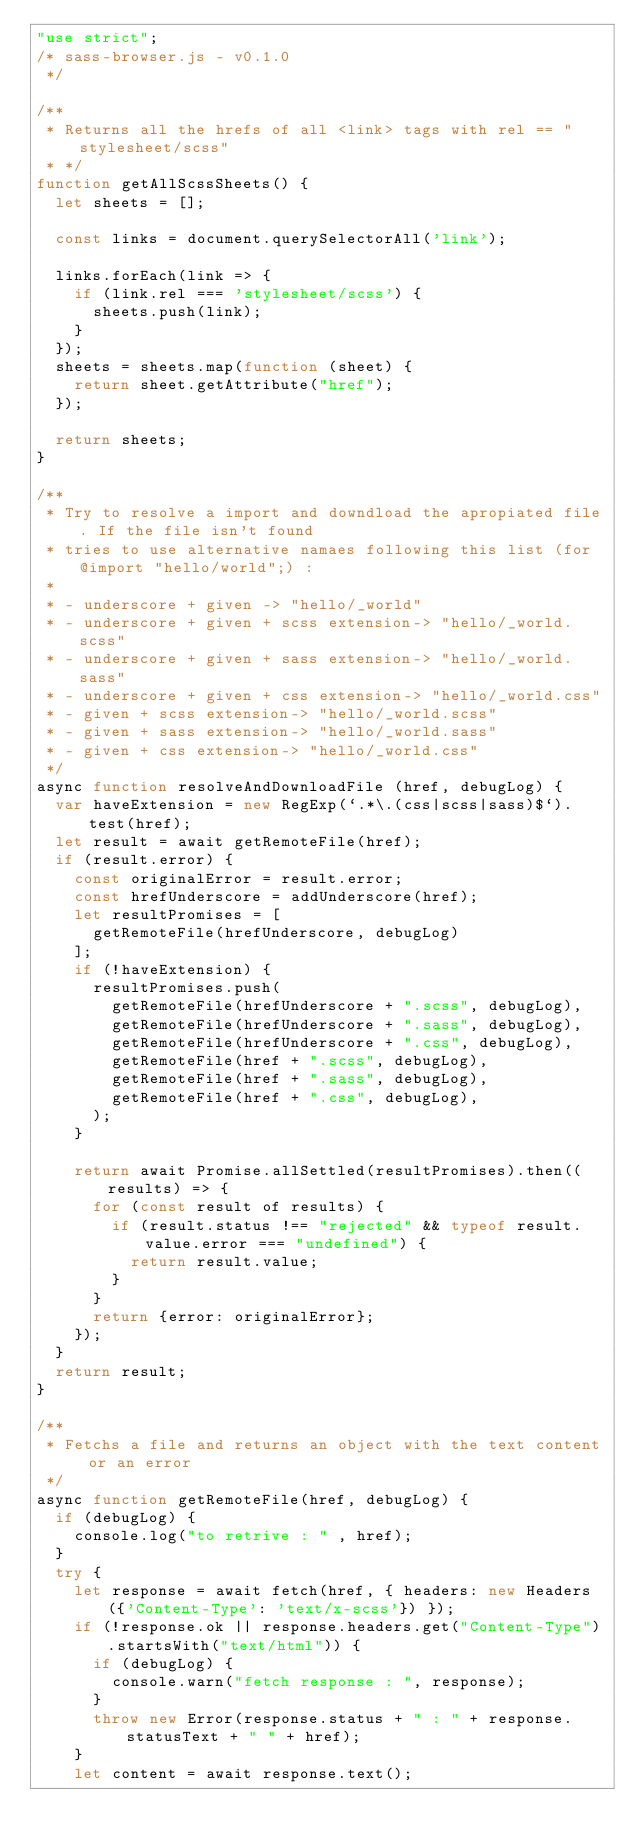Convert code to text. <code><loc_0><loc_0><loc_500><loc_500><_JavaScript_>"use strict";
/* sass-browser.js - v0.1.0
 */

/**
 * Returns all the hrefs of all <link> tags with rel == "stylesheet/scss"
 * */
function getAllScssSheets() {
  let sheets = [];

  const links = document.querySelectorAll('link');

  links.forEach(link => {
    if (link.rel === 'stylesheet/scss') {
      sheets.push(link);
    }
  });
  sheets = sheets.map(function (sheet) {
    return sheet.getAttribute("href");
  });

  return sheets;
}

/**
 * Try to resolve a import and downdload the apropiated file. If the file isn't found
 * tries to use alternative namaes following this list (for @import "hello/world";) :
 *
 * - underscore + given -> "hello/_world"
 * - underscore + given + scss extension-> "hello/_world.scss"
 * - underscore + given + sass extension-> "hello/_world.sass"
 * - underscore + given + css extension-> "hello/_world.css"
 * - given + scss extension-> "hello/_world.scss"
 * - given + sass extension-> "hello/_world.sass"
 * - given + css extension-> "hello/_world.css"
 */
async function resolveAndDownloadFile (href, debugLog) {
  var haveExtension = new RegExp(`.*\.(css|scss|sass)$`).test(href);
  let result = await getRemoteFile(href);
  if (result.error) {
    const originalError = result.error;
    const hrefUnderscore = addUnderscore(href);
    let resultPromises = [
      getRemoteFile(hrefUnderscore, debugLog)
    ];
    if (!haveExtension) {
      resultPromises.push(
        getRemoteFile(hrefUnderscore + ".scss", debugLog),
        getRemoteFile(hrefUnderscore + ".sass", debugLog),
        getRemoteFile(hrefUnderscore + ".css", debugLog),
        getRemoteFile(href + ".scss", debugLog),
        getRemoteFile(href + ".sass", debugLog),
        getRemoteFile(href + ".css", debugLog),
      );
    }

    return await Promise.allSettled(resultPromises).then((results) => {
      for (const result of results) {
        if (result.status !== "rejected" && typeof result.value.error === "undefined") {
          return result.value;
        }
      } 
      return {error: originalError};
    });
  }
  return result;
}

/**
 * Fetchs a file and returns an object with the text content or an error
 */
async function getRemoteFile(href, debugLog) {
  if (debugLog) {
    console.log("to retrive : " , href);
  }
  try {
    let response = await fetch(href, { headers: new Headers({'Content-Type': 'text/x-scss'}) });
    if (!response.ok || response.headers.get("Content-Type").startsWith("text/html")) {
      if (debugLog) {
        console.warn("fetch response : ", response);
      }
      throw new Error(response.status + " : " + response.statusText + " " + href);
    }
    let content = await response.text();</code> 